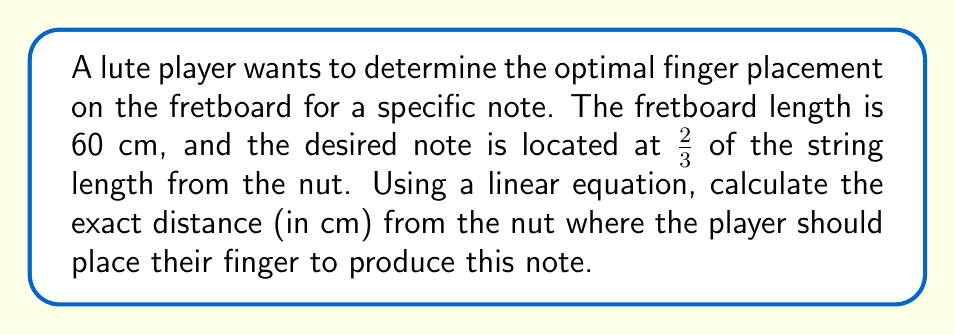Can you answer this question? Let's approach this step-by-step:

1) We can model the relationship between string length and pitch using a linear equation. Let $x$ be the distance from the nut, and $y$ be the fraction of the string length that vibrates.

2) We know two points on this line:
   - At the nut: $(0, 1)$ (full string length vibrates)
   - At the bridge: $(60, 0)$ (no string vibrates)

3) We can use the point-slope form of a line to create our equation:
   $$ y - y_1 = m(x - x_1) $$

4) The slope $m$ can be calculated:
   $$ m = \frac{y_2 - y_1}{x_2 - x_1} = \frac{0 - 1}{60 - 0} = -\frac{1}{60} $$

5) Using the point $(0, 1)$, our equation becomes:
   $$ y - 1 = -\frac{1}{60}(x - 0) $$

6) Simplifying:
   $$ y = -\frac{1}{60}x + 1 $$

7) We want the point where $y = \frac{2}{3}$ (as the desired note is at 2/3 of the string length). Substituting:
   $$ \frac{2}{3} = -\frac{1}{60}x + 1 $$

8) Solving for $x$:
   $$ -\frac{1}{3} = -\frac{1}{60}x $$
   $$ x = 20 $$

Therefore, the player should place their finger 20 cm from the nut.
Answer: 20 cm 